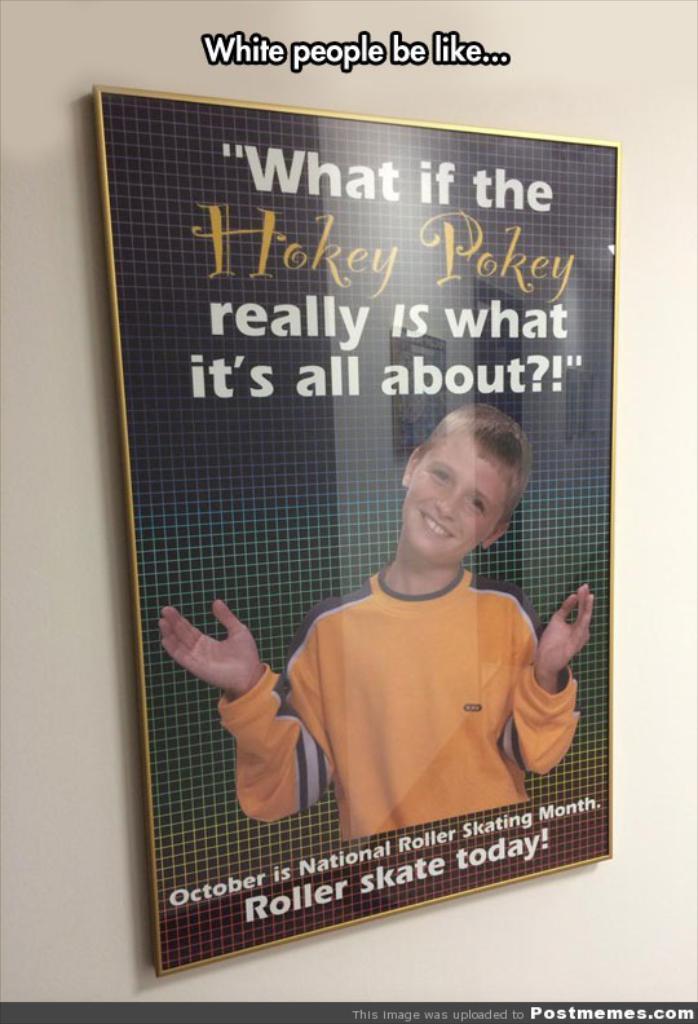When is national roller skating month?
Ensure brevity in your answer.  October. 